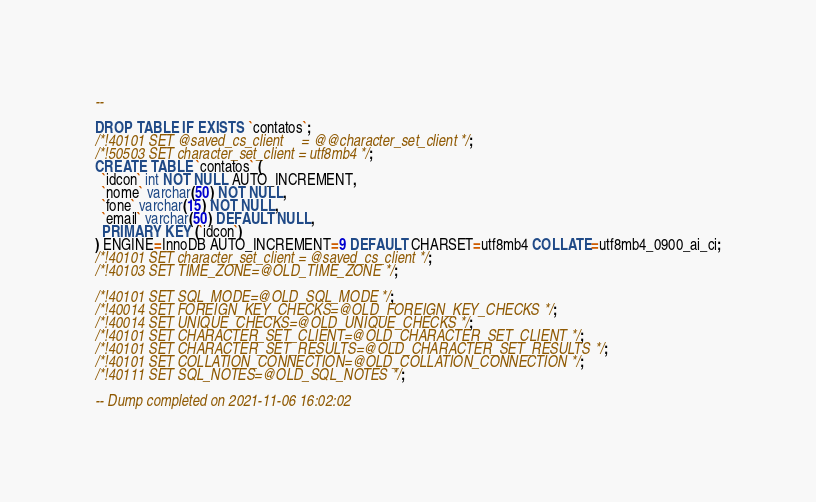Convert code to text. <code><loc_0><loc_0><loc_500><loc_500><_SQL_>--

DROP TABLE IF EXISTS `contatos`;
/*!40101 SET @saved_cs_client     = @@character_set_client */;
/*!50503 SET character_set_client = utf8mb4 */;
CREATE TABLE `contatos` (
  `idcon` int NOT NULL AUTO_INCREMENT,
  `nome` varchar(50) NOT NULL,
  `fone` varchar(15) NOT NULL,
  `email` varchar(50) DEFAULT NULL,
  PRIMARY KEY (`idcon`)
) ENGINE=InnoDB AUTO_INCREMENT=9 DEFAULT CHARSET=utf8mb4 COLLATE=utf8mb4_0900_ai_ci;
/*!40101 SET character_set_client = @saved_cs_client */;
/*!40103 SET TIME_ZONE=@OLD_TIME_ZONE */;

/*!40101 SET SQL_MODE=@OLD_SQL_MODE */;
/*!40014 SET FOREIGN_KEY_CHECKS=@OLD_FOREIGN_KEY_CHECKS */;
/*!40014 SET UNIQUE_CHECKS=@OLD_UNIQUE_CHECKS */;
/*!40101 SET CHARACTER_SET_CLIENT=@OLD_CHARACTER_SET_CLIENT */;
/*!40101 SET CHARACTER_SET_RESULTS=@OLD_CHARACTER_SET_RESULTS */;
/*!40101 SET COLLATION_CONNECTION=@OLD_COLLATION_CONNECTION */;
/*!40111 SET SQL_NOTES=@OLD_SQL_NOTES */;

-- Dump completed on 2021-11-06 16:02:02
</code> 